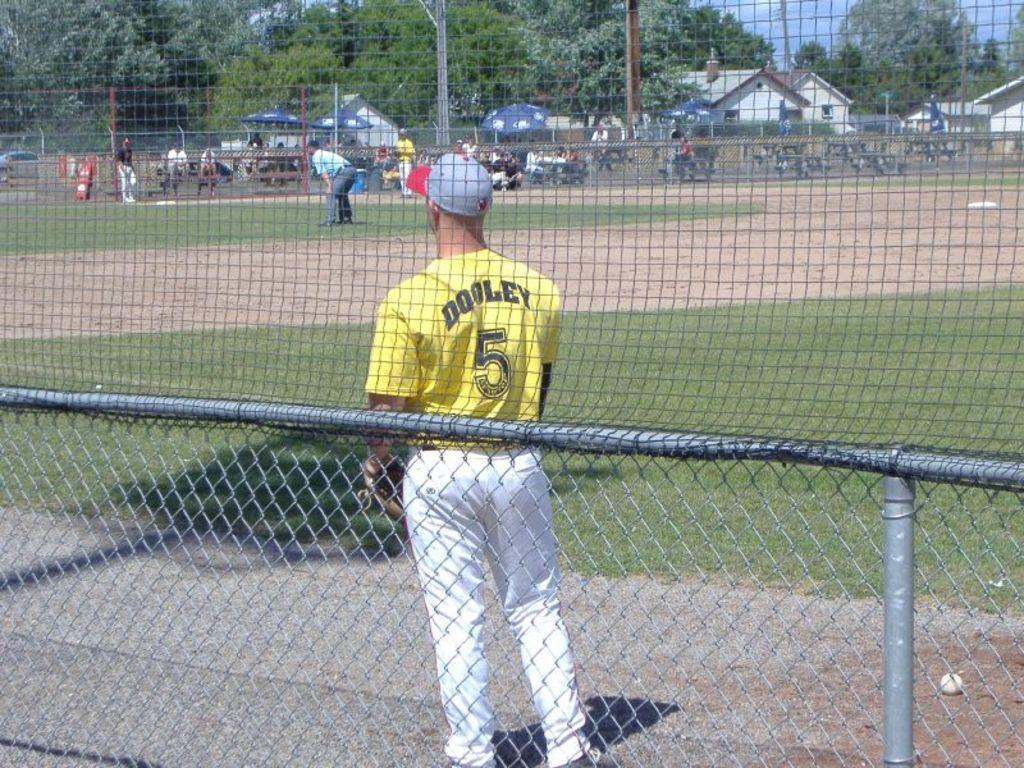Provide a one-sentence caption for the provided image. Baseball player Dooley is wearing the yellow number 5 shirt. 